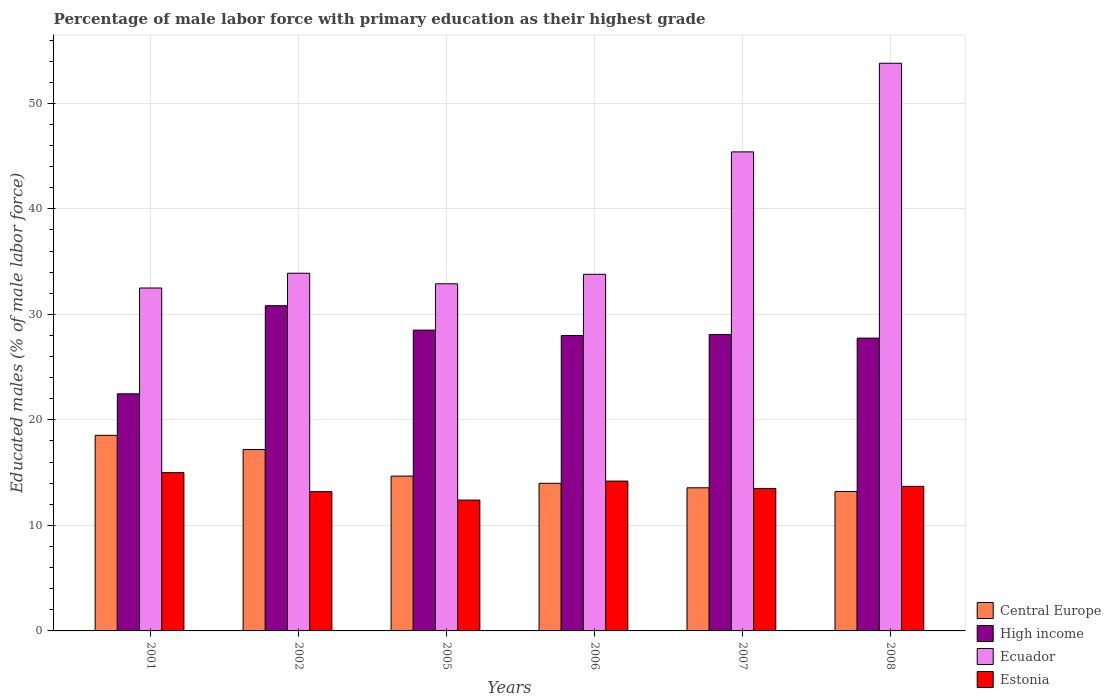Are the number of bars on each tick of the X-axis equal?
Ensure brevity in your answer.  Yes. How many bars are there on the 3rd tick from the right?
Ensure brevity in your answer.  4. In how many cases, is the number of bars for a given year not equal to the number of legend labels?
Provide a short and direct response. 0. What is the percentage of male labor force with primary education in High income in 2005?
Your answer should be compact. 28.51. Across all years, what is the maximum percentage of male labor force with primary education in Central Europe?
Ensure brevity in your answer.  18.54. Across all years, what is the minimum percentage of male labor force with primary education in Ecuador?
Offer a terse response. 32.5. In which year was the percentage of male labor force with primary education in Ecuador minimum?
Give a very brief answer. 2001. What is the total percentage of male labor force with primary education in High income in the graph?
Offer a terse response. 165.64. What is the difference between the percentage of male labor force with primary education in Central Europe in 2002 and that in 2006?
Ensure brevity in your answer.  3.2. What is the difference between the percentage of male labor force with primary education in Estonia in 2005 and the percentage of male labor force with primary education in Ecuador in 2006?
Ensure brevity in your answer.  -21.4. What is the average percentage of male labor force with primary education in Central Europe per year?
Offer a terse response. 15.2. In the year 2001, what is the difference between the percentage of male labor force with primary education in Central Europe and percentage of male labor force with primary education in High income?
Give a very brief answer. -3.93. In how many years, is the percentage of male labor force with primary education in Estonia greater than 22 %?
Ensure brevity in your answer.  0. What is the ratio of the percentage of male labor force with primary education in High income in 2001 to that in 2005?
Provide a short and direct response. 0.79. Is the percentage of male labor force with primary education in Estonia in 2001 less than that in 2005?
Your response must be concise. No. Is the difference between the percentage of male labor force with primary education in Central Europe in 2002 and 2005 greater than the difference between the percentage of male labor force with primary education in High income in 2002 and 2005?
Provide a short and direct response. Yes. What is the difference between the highest and the second highest percentage of male labor force with primary education in High income?
Your answer should be compact. 2.31. What is the difference between the highest and the lowest percentage of male labor force with primary education in High income?
Make the answer very short. 8.35. What does the 1st bar from the right in 2006 represents?
Provide a succinct answer. Estonia. How many bars are there?
Ensure brevity in your answer.  24. What is the difference between two consecutive major ticks on the Y-axis?
Offer a very short reply. 10. Does the graph contain any zero values?
Your response must be concise. No. Where does the legend appear in the graph?
Your response must be concise. Bottom right. How many legend labels are there?
Give a very brief answer. 4. How are the legend labels stacked?
Offer a very short reply. Vertical. What is the title of the graph?
Your answer should be very brief. Percentage of male labor force with primary education as their highest grade. What is the label or title of the X-axis?
Your answer should be compact. Years. What is the label or title of the Y-axis?
Keep it short and to the point. Educated males (% of male labor force). What is the Educated males (% of male labor force) in Central Europe in 2001?
Offer a terse response. 18.54. What is the Educated males (% of male labor force) of High income in 2001?
Keep it short and to the point. 22.47. What is the Educated males (% of male labor force) in Ecuador in 2001?
Provide a short and direct response. 32.5. What is the Educated males (% of male labor force) of Estonia in 2001?
Your response must be concise. 15. What is the Educated males (% of male labor force) of Central Europe in 2002?
Give a very brief answer. 17.19. What is the Educated males (% of male labor force) in High income in 2002?
Offer a very short reply. 30.82. What is the Educated males (% of male labor force) of Ecuador in 2002?
Make the answer very short. 33.9. What is the Educated males (% of male labor force) of Estonia in 2002?
Provide a short and direct response. 13.2. What is the Educated males (% of male labor force) in Central Europe in 2005?
Your response must be concise. 14.67. What is the Educated males (% of male labor force) in High income in 2005?
Your answer should be compact. 28.51. What is the Educated males (% of male labor force) of Ecuador in 2005?
Your answer should be very brief. 32.9. What is the Educated males (% of male labor force) in Estonia in 2005?
Offer a terse response. 12.4. What is the Educated males (% of male labor force) of Central Europe in 2006?
Your answer should be very brief. 13.99. What is the Educated males (% of male labor force) in High income in 2006?
Offer a terse response. 28. What is the Educated males (% of male labor force) in Ecuador in 2006?
Offer a very short reply. 33.8. What is the Educated males (% of male labor force) of Estonia in 2006?
Offer a terse response. 14.2. What is the Educated males (% of male labor force) of Central Europe in 2007?
Provide a short and direct response. 13.57. What is the Educated males (% of male labor force) of High income in 2007?
Offer a very short reply. 28.09. What is the Educated males (% of male labor force) of Ecuador in 2007?
Offer a very short reply. 45.4. What is the Educated males (% of male labor force) in Central Europe in 2008?
Keep it short and to the point. 13.22. What is the Educated males (% of male labor force) in High income in 2008?
Make the answer very short. 27.75. What is the Educated males (% of male labor force) in Ecuador in 2008?
Offer a very short reply. 53.8. What is the Educated males (% of male labor force) in Estonia in 2008?
Give a very brief answer. 13.7. Across all years, what is the maximum Educated males (% of male labor force) in Central Europe?
Give a very brief answer. 18.54. Across all years, what is the maximum Educated males (% of male labor force) in High income?
Provide a short and direct response. 30.82. Across all years, what is the maximum Educated males (% of male labor force) of Ecuador?
Offer a terse response. 53.8. Across all years, what is the maximum Educated males (% of male labor force) in Estonia?
Offer a terse response. 15. Across all years, what is the minimum Educated males (% of male labor force) of Central Europe?
Make the answer very short. 13.22. Across all years, what is the minimum Educated males (% of male labor force) of High income?
Your response must be concise. 22.47. Across all years, what is the minimum Educated males (% of male labor force) in Ecuador?
Provide a short and direct response. 32.5. Across all years, what is the minimum Educated males (% of male labor force) of Estonia?
Offer a terse response. 12.4. What is the total Educated males (% of male labor force) in Central Europe in the graph?
Offer a very short reply. 91.18. What is the total Educated males (% of male labor force) of High income in the graph?
Offer a very short reply. 165.64. What is the total Educated males (% of male labor force) in Ecuador in the graph?
Give a very brief answer. 232.3. What is the difference between the Educated males (% of male labor force) of Central Europe in 2001 and that in 2002?
Your response must be concise. 1.35. What is the difference between the Educated males (% of male labor force) of High income in 2001 and that in 2002?
Provide a short and direct response. -8.35. What is the difference between the Educated males (% of male labor force) in Estonia in 2001 and that in 2002?
Offer a very short reply. 1.8. What is the difference between the Educated males (% of male labor force) in Central Europe in 2001 and that in 2005?
Your response must be concise. 3.87. What is the difference between the Educated males (% of male labor force) of High income in 2001 and that in 2005?
Your response must be concise. -6.04. What is the difference between the Educated males (% of male labor force) in Ecuador in 2001 and that in 2005?
Your answer should be very brief. -0.4. What is the difference between the Educated males (% of male labor force) in Central Europe in 2001 and that in 2006?
Keep it short and to the point. 4.55. What is the difference between the Educated males (% of male labor force) in High income in 2001 and that in 2006?
Offer a terse response. -5.53. What is the difference between the Educated males (% of male labor force) in Ecuador in 2001 and that in 2006?
Give a very brief answer. -1.3. What is the difference between the Educated males (% of male labor force) of Central Europe in 2001 and that in 2007?
Ensure brevity in your answer.  4.97. What is the difference between the Educated males (% of male labor force) in High income in 2001 and that in 2007?
Offer a terse response. -5.62. What is the difference between the Educated males (% of male labor force) in Ecuador in 2001 and that in 2007?
Offer a very short reply. -12.9. What is the difference between the Educated males (% of male labor force) of Central Europe in 2001 and that in 2008?
Provide a short and direct response. 5.32. What is the difference between the Educated males (% of male labor force) in High income in 2001 and that in 2008?
Offer a terse response. -5.28. What is the difference between the Educated males (% of male labor force) in Ecuador in 2001 and that in 2008?
Offer a very short reply. -21.3. What is the difference between the Educated males (% of male labor force) of Central Europe in 2002 and that in 2005?
Your answer should be compact. 2.52. What is the difference between the Educated males (% of male labor force) of High income in 2002 and that in 2005?
Your answer should be compact. 2.31. What is the difference between the Educated males (% of male labor force) in Estonia in 2002 and that in 2005?
Offer a very short reply. 0.8. What is the difference between the Educated males (% of male labor force) of Central Europe in 2002 and that in 2006?
Ensure brevity in your answer.  3.2. What is the difference between the Educated males (% of male labor force) in High income in 2002 and that in 2006?
Offer a terse response. 2.82. What is the difference between the Educated males (% of male labor force) in Central Europe in 2002 and that in 2007?
Make the answer very short. 3.62. What is the difference between the Educated males (% of male labor force) in High income in 2002 and that in 2007?
Give a very brief answer. 2.73. What is the difference between the Educated males (% of male labor force) of Ecuador in 2002 and that in 2007?
Provide a succinct answer. -11.5. What is the difference between the Educated males (% of male labor force) in Central Europe in 2002 and that in 2008?
Your answer should be compact. 3.97. What is the difference between the Educated males (% of male labor force) in High income in 2002 and that in 2008?
Your answer should be compact. 3.07. What is the difference between the Educated males (% of male labor force) of Ecuador in 2002 and that in 2008?
Ensure brevity in your answer.  -19.9. What is the difference between the Educated males (% of male labor force) in Central Europe in 2005 and that in 2006?
Your answer should be compact. 0.68. What is the difference between the Educated males (% of male labor force) of High income in 2005 and that in 2006?
Provide a short and direct response. 0.51. What is the difference between the Educated males (% of male labor force) in Ecuador in 2005 and that in 2006?
Offer a terse response. -0.9. What is the difference between the Educated males (% of male labor force) in Estonia in 2005 and that in 2006?
Offer a very short reply. -1.8. What is the difference between the Educated males (% of male labor force) in Central Europe in 2005 and that in 2007?
Provide a short and direct response. 1.11. What is the difference between the Educated males (% of male labor force) in High income in 2005 and that in 2007?
Give a very brief answer. 0.42. What is the difference between the Educated males (% of male labor force) in Ecuador in 2005 and that in 2007?
Provide a succinct answer. -12.5. What is the difference between the Educated males (% of male labor force) in Estonia in 2005 and that in 2007?
Provide a short and direct response. -1.1. What is the difference between the Educated males (% of male labor force) in Central Europe in 2005 and that in 2008?
Your response must be concise. 1.46. What is the difference between the Educated males (% of male labor force) in High income in 2005 and that in 2008?
Provide a succinct answer. 0.76. What is the difference between the Educated males (% of male labor force) of Ecuador in 2005 and that in 2008?
Your response must be concise. -20.9. What is the difference between the Educated males (% of male labor force) of Estonia in 2005 and that in 2008?
Give a very brief answer. -1.3. What is the difference between the Educated males (% of male labor force) in Central Europe in 2006 and that in 2007?
Offer a terse response. 0.43. What is the difference between the Educated males (% of male labor force) in High income in 2006 and that in 2007?
Offer a very short reply. -0.09. What is the difference between the Educated males (% of male labor force) of Estonia in 2006 and that in 2007?
Your answer should be compact. 0.7. What is the difference between the Educated males (% of male labor force) in Central Europe in 2006 and that in 2008?
Keep it short and to the point. 0.78. What is the difference between the Educated males (% of male labor force) of High income in 2006 and that in 2008?
Ensure brevity in your answer.  0.25. What is the difference between the Educated males (% of male labor force) in Estonia in 2006 and that in 2008?
Provide a short and direct response. 0.5. What is the difference between the Educated males (% of male labor force) of Central Europe in 2007 and that in 2008?
Ensure brevity in your answer.  0.35. What is the difference between the Educated males (% of male labor force) in High income in 2007 and that in 2008?
Give a very brief answer. 0.34. What is the difference between the Educated males (% of male labor force) of Estonia in 2007 and that in 2008?
Keep it short and to the point. -0.2. What is the difference between the Educated males (% of male labor force) of Central Europe in 2001 and the Educated males (% of male labor force) of High income in 2002?
Your answer should be compact. -12.28. What is the difference between the Educated males (% of male labor force) of Central Europe in 2001 and the Educated males (% of male labor force) of Ecuador in 2002?
Provide a short and direct response. -15.36. What is the difference between the Educated males (% of male labor force) in Central Europe in 2001 and the Educated males (% of male labor force) in Estonia in 2002?
Provide a short and direct response. 5.34. What is the difference between the Educated males (% of male labor force) in High income in 2001 and the Educated males (% of male labor force) in Ecuador in 2002?
Give a very brief answer. -11.43. What is the difference between the Educated males (% of male labor force) of High income in 2001 and the Educated males (% of male labor force) of Estonia in 2002?
Make the answer very short. 9.27. What is the difference between the Educated males (% of male labor force) of Ecuador in 2001 and the Educated males (% of male labor force) of Estonia in 2002?
Provide a succinct answer. 19.3. What is the difference between the Educated males (% of male labor force) in Central Europe in 2001 and the Educated males (% of male labor force) in High income in 2005?
Keep it short and to the point. -9.97. What is the difference between the Educated males (% of male labor force) in Central Europe in 2001 and the Educated males (% of male labor force) in Ecuador in 2005?
Provide a short and direct response. -14.36. What is the difference between the Educated males (% of male labor force) of Central Europe in 2001 and the Educated males (% of male labor force) of Estonia in 2005?
Keep it short and to the point. 6.14. What is the difference between the Educated males (% of male labor force) of High income in 2001 and the Educated males (% of male labor force) of Ecuador in 2005?
Offer a terse response. -10.43. What is the difference between the Educated males (% of male labor force) of High income in 2001 and the Educated males (% of male labor force) of Estonia in 2005?
Make the answer very short. 10.07. What is the difference between the Educated males (% of male labor force) of Ecuador in 2001 and the Educated males (% of male labor force) of Estonia in 2005?
Make the answer very short. 20.1. What is the difference between the Educated males (% of male labor force) in Central Europe in 2001 and the Educated males (% of male labor force) in High income in 2006?
Your response must be concise. -9.46. What is the difference between the Educated males (% of male labor force) in Central Europe in 2001 and the Educated males (% of male labor force) in Ecuador in 2006?
Your answer should be compact. -15.26. What is the difference between the Educated males (% of male labor force) of Central Europe in 2001 and the Educated males (% of male labor force) of Estonia in 2006?
Keep it short and to the point. 4.34. What is the difference between the Educated males (% of male labor force) in High income in 2001 and the Educated males (% of male labor force) in Ecuador in 2006?
Your response must be concise. -11.33. What is the difference between the Educated males (% of male labor force) in High income in 2001 and the Educated males (% of male labor force) in Estonia in 2006?
Make the answer very short. 8.27. What is the difference between the Educated males (% of male labor force) of Central Europe in 2001 and the Educated males (% of male labor force) of High income in 2007?
Make the answer very short. -9.55. What is the difference between the Educated males (% of male labor force) of Central Europe in 2001 and the Educated males (% of male labor force) of Ecuador in 2007?
Provide a succinct answer. -26.86. What is the difference between the Educated males (% of male labor force) in Central Europe in 2001 and the Educated males (% of male labor force) in Estonia in 2007?
Provide a succinct answer. 5.04. What is the difference between the Educated males (% of male labor force) of High income in 2001 and the Educated males (% of male labor force) of Ecuador in 2007?
Your answer should be very brief. -22.93. What is the difference between the Educated males (% of male labor force) in High income in 2001 and the Educated males (% of male labor force) in Estonia in 2007?
Offer a terse response. 8.97. What is the difference between the Educated males (% of male labor force) of Central Europe in 2001 and the Educated males (% of male labor force) of High income in 2008?
Make the answer very short. -9.21. What is the difference between the Educated males (% of male labor force) in Central Europe in 2001 and the Educated males (% of male labor force) in Ecuador in 2008?
Offer a very short reply. -35.26. What is the difference between the Educated males (% of male labor force) in Central Europe in 2001 and the Educated males (% of male labor force) in Estonia in 2008?
Offer a very short reply. 4.84. What is the difference between the Educated males (% of male labor force) in High income in 2001 and the Educated males (% of male labor force) in Ecuador in 2008?
Give a very brief answer. -31.33. What is the difference between the Educated males (% of male labor force) of High income in 2001 and the Educated males (% of male labor force) of Estonia in 2008?
Make the answer very short. 8.77. What is the difference between the Educated males (% of male labor force) in Central Europe in 2002 and the Educated males (% of male labor force) in High income in 2005?
Give a very brief answer. -11.32. What is the difference between the Educated males (% of male labor force) in Central Europe in 2002 and the Educated males (% of male labor force) in Ecuador in 2005?
Give a very brief answer. -15.71. What is the difference between the Educated males (% of male labor force) in Central Europe in 2002 and the Educated males (% of male labor force) in Estonia in 2005?
Your response must be concise. 4.79. What is the difference between the Educated males (% of male labor force) of High income in 2002 and the Educated males (% of male labor force) of Ecuador in 2005?
Your answer should be compact. -2.08. What is the difference between the Educated males (% of male labor force) of High income in 2002 and the Educated males (% of male labor force) of Estonia in 2005?
Ensure brevity in your answer.  18.42. What is the difference between the Educated males (% of male labor force) in Central Europe in 2002 and the Educated males (% of male labor force) in High income in 2006?
Provide a short and direct response. -10.81. What is the difference between the Educated males (% of male labor force) in Central Europe in 2002 and the Educated males (% of male labor force) in Ecuador in 2006?
Ensure brevity in your answer.  -16.61. What is the difference between the Educated males (% of male labor force) of Central Europe in 2002 and the Educated males (% of male labor force) of Estonia in 2006?
Your response must be concise. 2.99. What is the difference between the Educated males (% of male labor force) of High income in 2002 and the Educated males (% of male labor force) of Ecuador in 2006?
Keep it short and to the point. -2.98. What is the difference between the Educated males (% of male labor force) in High income in 2002 and the Educated males (% of male labor force) in Estonia in 2006?
Give a very brief answer. 16.62. What is the difference between the Educated males (% of male labor force) in Ecuador in 2002 and the Educated males (% of male labor force) in Estonia in 2006?
Provide a short and direct response. 19.7. What is the difference between the Educated males (% of male labor force) in Central Europe in 2002 and the Educated males (% of male labor force) in High income in 2007?
Your answer should be compact. -10.9. What is the difference between the Educated males (% of male labor force) in Central Europe in 2002 and the Educated males (% of male labor force) in Ecuador in 2007?
Offer a terse response. -28.21. What is the difference between the Educated males (% of male labor force) in Central Europe in 2002 and the Educated males (% of male labor force) in Estonia in 2007?
Ensure brevity in your answer.  3.69. What is the difference between the Educated males (% of male labor force) in High income in 2002 and the Educated males (% of male labor force) in Ecuador in 2007?
Provide a short and direct response. -14.58. What is the difference between the Educated males (% of male labor force) in High income in 2002 and the Educated males (% of male labor force) in Estonia in 2007?
Offer a very short reply. 17.32. What is the difference between the Educated males (% of male labor force) in Ecuador in 2002 and the Educated males (% of male labor force) in Estonia in 2007?
Your answer should be compact. 20.4. What is the difference between the Educated males (% of male labor force) in Central Europe in 2002 and the Educated males (% of male labor force) in High income in 2008?
Offer a very short reply. -10.56. What is the difference between the Educated males (% of male labor force) in Central Europe in 2002 and the Educated males (% of male labor force) in Ecuador in 2008?
Ensure brevity in your answer.  -36.61. What is the difference between the Educated males (% of male labor force) in Central Europe in 2002 and the Educated males (% of male labor force) in Estonia in 2008?
Your answer should be compact. 3.49. What is the difference between the Educated males (% of male labor force) of High income in 2002 and the Educated males (% of male labor force) of Ecuador in 2008?
Give a very brief answer. -22.98. What is the difference between the Educated males (% of male labor force) of High income in 2002 and the Educated males (% of male labor force) of Estonia in 2008?
Offer a terse response. 17.12. What is the difference between the Educated males (% of male labor force) in Ecuador in 2002 and the Educated males (% of male labor force) in Estonia in 2008?
Ensure brevity in your answer.  20.2. What is the difference between the Educated males (% of male labor force) of Central Europe in 2005 and the Educated males (% of male labor force) of High income in 2006?
Make the answer very short. -13.32. What is the difference between the Educated males (% of male labor force) in Central Europe in 2005 and the Educated males (% of male labor force) in Ecuador in 2006?
Give a very brief answer. -19.13. What is the difference between the Educated males (% of male labor force) of Central Europe in 2005 and the Educated males (% of male labor force) of Estonia in 2006?
Give a very brief answer. 0.47. What is the difference between the Educated males (% of male labor force) in High income in 2005 and the Educated males (% of male labor force) in Ecuador in 2006?
Keep it short and to the point. -5.29. What is the difference between the Educated males (% of male labor force) of High income in 2005 and the Educated males (% of male labor force) of Estonia in 2006?
Offer a very short reply. 14.31. What is the difference between the Educated males (% of male labor force) of Ecuador in 2005 and the Educated males (% of male labor force) of Estonia in 2006?
Your answer should be compact. 18.7. What is the difference between the Educated males (% of male labor force) in Central Europe in 2005 and the Educated males (% of male labor force) in High income in 2007?
Offer a very short reply. -13.42. What is the difference between the Educated males (% of male labor force) of Central Europe in 2005 and the Educated males (% of male labor force) of Ecuador in 2007?
Keep it short and to the point. -30.73. What is the difference between the Educated males (% of male labor force) of Central Europe in 2005 and the Educated males (% of male labor force) of Estonia in 2007?
Provide a short and direct response. 1.17. What is the difference between the Educated males (% of male labor force) of High income in 2005 and the Educated males (% of male labor force) of Ecuador in 2007?
Make the answer very short. -16.89. What is the difference between the Educated males (% of male labor force) in High income in 2005 and the Educated males (% of male labor force) in Estonia in 2007?
Provide a short and direct response. 15.01. What is the difference between the Educated males (% of male labor force) in Ecuador in 2005 and the Educated males (% of male labor force) in Estonia in 2007?
Provide a short and direct response. 19.4. What is the difference between the Educated males (% of male labor force) of Central Europe in 2005 and the Educated males (% of male labor force) of High income in 2008?
Keep it short and to the point. -13.08. What is the difference between the Educated males (% of male labor force) of Central Europe in 2005 and the Educated males (% of male labor force) of Ecuador in 2008?
Your response must be concise. -39.13. What is the difference between the Educated males (% of male labor force) of Central Europe in 2005 and the Educated males (% of male labor force) of Estonia in 2008?
Offer a very short reply. 0.97. What is the difference between the Educated males (% of male labor force) in High income in 2005 and the Educated males (% of male labor force) in Ecuador in 2008?
Give a very brief answer. -25.29. What is the difference between the Educated males (% of male labor force) in High income in 2005 and the Educated males (% of male labor force) in Estonia in 2008?
Provide a short and direct response. 14.81. What is the difference between the Educated males (% of male labor force) in Ecuador in 2005 and the Educated males (% of male labor force) in Estonia in 2008?
Keep it short and to the point. 19.2. What is the difference between the Educated males (% of male labor force) of Central Europe in 2006 and the Educated males (% of male labor force) of High income in 2007?
Your answer should be very brief. -14.1. What is the difference between the Educated males (% of male labor force) in Central Europe in 2006 and the Educated males (% of male labor force) in Ecuador in 2007?
Ensure brevity in your answer.  -31.41. What is the difference between the Educated males (% of male labor force) in Central Europe in 2006 and the Educated males (% of male labor force) in Estonia in 2007?
Your answer should be compact. 0.49. What is the difference between the Educated males (% of male labor force) in High income in 2006 and the Educated males (% of male labor force) in Ecuador in 2007?
Offer a very short reply. -17.4. What is the difference between the Educated males (% of male labor force) of High income in 2006 and the Educated males (% of male labor force) of Estonia in 2007?
Make the answer very short. 14.5. What is the difference between the Educated males (% of male labor force) in Ecuador in 2006 and the Educated males (% of male labor force) in Estonia in 2007?
Offer a terse response. 20.3. What is the difference between the Educated males (% of male labor force) of Central Europe in 2006 and the Educated males (% of male labor force) of High income in 2008?
Keep it short and to the point. -13.76. What is the difference between the Educated males (% of male labor force) in Central Europe in 2006 and the Educated males (% of male labor force) in Ecuador in 2008?
Provide a succinct answer. -39.81. What is the difference between the Educated males (% of male labor force) of Central Europe in 2006 and the Educated males (% of male labor force) of Estonia in 2008?
Ensure brevity in your answer.  0.29. What is the difference between the Educated males (% of male labor force) in High income in 2006 and the Educated males (% of male labor force) in Ecuador in 2008?
Your answer should be compact. -25.8. What is the difference between the Educated males (% of male labor force) in High income in 2006 and the Educated males (% of male labor force) in Estonia in 2008?
Your response must be concise. 14.3. What is the difference between the Educated males (% of male labor force) of Ecuador in 2006 and the Educated males (% of male labor force) of Estonia in 2008?
Your response must be concise. 20.1. What is the difference between the Educated males (% of male labor force) in Central Europe in 2007 and the Educated males (% of male labor force) in High income in 2008?
Keep it short and to the point. -14.19. What is the difference between the Educated males (% of male labor force) of Central Europe in 2007 and the Educated males (% of male labor force) of Ecuador in 2008?
Ensure brevity in your answer.  -40.23. What is the difference between the Educated males (% of male labor force) of Central Europe in 2007 and the Educated males (% of male labor force) of Estonia in 2008?
Your answer should be compact. -0.13. What is the difference between the Educated males (% of male labor force) in High income in 2007 and the Educated males (% of male labor force) in Ecuador in 2008?
Provide a succinct answer. -25.71. What is the difference between the Educated males (% of male labor force) in High income in 2007 and the Educated males (% of male labor force) in Estonia in 2008?
Give a very brief answer. 14.39. What is the difference between the Educated males (% of male labor force) in Ecuador in 2007 and the Educated males (% of male labor force) in Estonia in 2008?
Your response must be concise. 31.7. What is the average Educated males (% of male labor force) of Central Europe per year?
Make the answer very short. 15.2. What is the average Educated males (% of male labor force) of High income per year?
Your answer should be very brief. 27.61. What is the average Educated males (% of male labor force) in Ecuador per year?
Your response must be concise. 38.72. What is the average Educated males (% of male labor force) in Estonia per year?
Your response must be concise. 13.67. In the year 2001, what is the difference between the Educated males (% of male labor force) in Central Europe and Educated males (% of male labor force) in High income?
Provide a short and direct response. -3.93. In the year 2001, what is the difference between the Educated males (% of male labor force) of Central Europe and Educated males (% of male labor force) of Ecuador?
Offer a very short reply. -13.96. In the year 2001, what is the difference between the Educated males (% of male labor force) of Central Europe and Educated males (% of male labor force) of Estonia?
Provide a succinct answer. 3.54. In the year 2001, what is the difference between the Educated males (% of male labor force) in High income and Educated males (% of male labor force) in Ecuador?
Provide a succinct answer. -10.03. In the year 2001, what is the difference between the Educated males (% of male labor force) in High income and Educated males (% of male labor force) in Estonia?
Provide a short and direct response. 7.47. In the year 2002, what is the difference between the Educated males (% of male labor force) of Central Europe and Educated males (% of male labor force) of High income?
Your response must be concise. -13.63. In the year 2002, what is the difference between the Educated males (% of male labor force) of Central Europe and Educated males (% of male labor force) of Ecuador?
Your answer should be compact. -16.71. In the year 2002, what is the difference between the Educated males (% of male labor force) in Central Europe and Educated males (% of male labor force) in Estonia?
Ensure brevity in your answer.  3.99. In the year 2002, what is the difference between the Educated males (% of male labor force) of High income and Educated males (% of male labor force) of Ecuador?
Your answer should be compact. -3.08. In the year 2002, what is the difference between the Educated males (% of male labor force) in High income and Educated males (% of male labor force) in Estonia?
Make the answer very short. 17.62. In the year 2002, what is the difference between the Educated males (% of male labor force) in Ecuador and Educated males (% of male labor force) in Estonia?
Provide a succinct answer. 20.7. In the year 2005, what is the difference between the Educated males (% of male labor force) of Central Europe and Educated males (% of male labor force) of High income?
Offer a terse response. -13.84. In the year 2005, what is the difference between the Educated males (% of male labor force) of Central Europe and Educated males (% of male labor force) of Ecuador?
Offer a very short reply. -18.23. In the year 2005, what is the difference between the Educated males (% of male labor force) of Central Europe and Educated males (% of male labor force) of Estonia?
Provide a short and direct response. 2.27. In the year 2005, what is the difference between the Educated males (% of male labor force) in High income and Educated males (% of male labor force) in Ecuador?
Your answer should be very brief. -4.39. In the year 2005, what is the difference between the Educated males (% of male labor force) of High income and Educated males (% of male labor force) of Estonia?
Ensure brevity in your answer.  16.11. In the year 2006, what is the difference between the Educated males (% of male labor force) of Central Europe and Educated males (% of male labor force) of High income?
Your answer should be compact. -14. In the year 2006, what is the difference between the Educated males (% of male labor force) in Central Europe and Educated males (% of male labor force) in Ecuador?
Give a very brief answer. -19.81. In the year 2006, what is the difference between the Educated males (% of male labor force) of Central Europe and Educated males (% of male labor force) of Estonia?
Provide a short and direct response. -0.21. In the year 2006, what is the difference between the Educated males (% of male labor force) of High income and Educated males (% of male labor force) of Ecuador?
Provide a short and direct response. -5.8. In the year 2006, what is the difference between the Educated males (% of male labor force) in High income and Educated males (% of male labor force) in Estonia?
Your answer should be very brief. 13.8. In the year 2006, what is the difference between the Educated males (% of male labor force) in Ecuador and Educated males (% of male labor force) in Estonia?
Keep it short and to the point. 19.6. In the year 2007, what is the difference between the Educated males (% of male labor force) of Central Europe and Educated males (% of male labor force) of High income?
Provide a succinct answer. -14.52. In the year 2007, what is the difference between the Educated males (% of male labor force) in Central Europe and Educated males (% of male labor force) in Ecuador?
Offer a very short reply. -31.83. In the year 2007, what is the difference between the Educated males (% of male labor force) in Central Europe and Educated males (% of male labor force) in Estonia?
Provide a short and direct response. 0.07. In the year 2007, what is the difference between the Educated males (% of male labor force) in High income and Educated males (% of male labor force) in Ecuador?
Offer a very short reply. -17.31. In the year 2007, what is the difference between the Educated males (% of male labor force) of High income and Educated males (% of male labor force) of Estonia?
Make the answer very short. 14.59. In the year 2007, what is the difference between the Educated males (% of male labor force) of Ecuador and Educated males (% of male labor force) of Estonia?
Keep it short and to the point. 31.9. In the year 2008, what is the difference between the Educated males (% of male labor force) of Central Europe and Educated males (% of male labor force) of High income?
Your answer should be very brief. -14.53. In the year 2008, what is the difference between the Educated males (% of male labor force) of Central Europe and Educated males (% of male labor force) of Ecuador?
Make the answer very short. -40.58. In the year 2008, what is the difference between the Educated males (% of male labor force) of Central Europe and Educated males (% of male labor force) of Estonia?
Your answer should be compact. -0.48. In the year 2008, what is the difference between the Educated males (% of male labor force) of High income and Educated males (% of male labor force) of Ecuador?
Keep it short and to the point. -26.05. In the year 2008, what is the difference between the Educated males (% of male labor force) of High income and Educated males (% of male labor force) of Estonia?
Your answer should be very brief. 14.05. In the year 2008, what is the difference between the Educated males (% of male labor force) in Ecuador and Educated males (% of male labor force) in Estonia?
Keep it short and to the point. 40.1. What is the ratio of the Educated males (% of male labor force) of Central Europe in 2001 to that in 2002?
Your answer should be very brief. 1.08. What is the ratio of the Educated males (% of male labor force) of High income in 2001 to that in 2002?
Provide a short and direct response. 0.73. What is the ratio of the Educated males (% of male labor force) in Ecuador in 2001 to that in 2002?
Ensure brevity in your answer.  0.96. What is the ratio of the Educated males (% of male labor force) in Estonia in 2001 to that in 2002?
Provide a succinct answer. 1.14. What is the ratio of the Educated males (% of male labor force) in Central Europe in 2001 to that in 2005?
Keep it short and to the point. 1.26. What is the ratio of the Educated males (% of male labor force) of High income in 2001 to that in 2005?
Provide a succinct answer. 0.79. What is the ratio of the Educated males (% of male labor force) in Ecuador in 2001 to that in 2005?
Give a very brief answer. 0.99. What is the ratio of the Educated males (% of male labor force) of Estonia in 2001 to that in 2005?
Give a very brief answer. 1.21. What is the ratio of the Educated males (% of male labor force) of Central Europe in 2001 to that in 2006?
Your response must be concise. 1.32. What is the ratio of the Educated males (% of male labor force) of High income in 2001 to that in 2006?
Offer a terse response. 0.8. What is the ratio of the Educated males (% of male labor force) in Ecuador in 2001 to that in 2006?
Your answer should be very brief. 0.96. What is the ratio of the Educated males (% of male labor force) of Estonia in 2001 to that in 2006?
Provide a succinct answer. 1.06. What is the ratio of the Educated males (% of male labor force) in Central Europe in 2001 to that in 2007?
Offer a terse response. 1.37. What is the ratio of the Educated males (% of male labor force) of Ecuador in 2001 to that in 2007?
Offer a terse response. 0.72. What is the ratio of the Educated males (% of male labor force) of Central Europe in 2001 to that in 2008?
Keep it short and to the point. 1.4. What is the ratio of the Educated males (% of male labor force) in High income in 2001 to that in 2008?
Make the answer very short. 0.81. What is the ratio of the Educated males (% of male labor force) in Ecuador in 2001 to that in 2008?
Your answer should be very brief. 0.6. What is the ratio of the Educated males (% of male labor force) of Estonia in 2001 to that in 2008?
Keep it short and to the point. 1.09. What is the ratio of the Educated males (% of male labor force) of Central Europe in 2002 to that in 2005?
Ensure brevity in your answer.  1.17. What is the ratio of the Educated males (% of male labor force) in High income in 2002 to that in 2005?
Give a very brief answer. 1.08. What is the ratio of the Educated males (% of male labor force) in Ecuador in 2002 to that in 2005?
Ensure brevity in your answer.  1.03. What is the ratio of the Educated males (% of male labor force) in Estonia in 2002 to that in 2005?
Give a very brief answer. 1.06. What is the ratio of the Educated males (% of male labor force) in Central Europe in 2002 to that in 2006?
Provide a short and direct response. 1.23. What is the ratio of the Educated males (% of male labor force) in High income in 2002 to that in 2006?
Provide a succinct answer. 1.1. What is the ratio of the Educated males (% of male labor force) in Ecuador in 2002 to that in 2006?
Provide a short and direct response. 1. What is the ratio of the Educated males (% of male labor force) in Estonia in 2002 to that in 2006?
Offer a very short reply. 0.93. What is the ratio of the Educated males (% of male labor force) of Central Europe in 2002 to that in 2007?
Provide a succinct answer. 1.27. What is the ratio of the Educated males (% of male labor force) in High income in 2002 to that in 2007?
Provide a succinct answer. 1.1. What is the ratio of the Educated males (% of male labor force) in Ecuador in 2002 to that in 2007?
Provide a succinct answer. 0.75. What is the ratio of the Educated males (% of male labor force) of Estonia in 2002 to that in 2007?
Provide a succinct answer. 0.98. What is the ratio of the Educated males (% of male labor force) of Central Europe in 2002 to that in 2008?
Keep it short and to the point. 1.3. What is the ratio of the Educated males (% of male labor force) of High income in 2002 to that in 2008?
Offer a terse response. 1.11. What is the ratio of the Educated males (% of male labor force) in Ecuador in 2002 to that in 2008?
Keep it short and to the point. 0.63. What is the ratio of the Educated males (% of male labor force) of Estonia in 2002 to that in 2008?
Give a very brief answer. 0.96. What is the ratio of the Educated males (% of male labor force) of Central Europe in 2005 to that in 2006?
Offer a terse response. 1.05. What is the ratio of the Educated males (% of male labor force) in High income in 2005 to that in 2006?
Make the answer very short. 1.02. What is the ratio of the Educated males (% of male labor force) in Ecuador in 2005 to that in 2006?
Your answer should be compact. 0.97. What is the ratio of the Educated males (% of male labor force) in Estonia in 2005 to that in 2006?
Make the answer very short. 0.87. What is the ratio of the Educated males (% of male labor force) in Central Europe in 2005 to that in 2007?
Your answer should be compact. 1.08. What is the ratio of the Educated males (% of male labor force) of High income in 2005 to that in 2007?
Your answer should be very brief. 1.01. What is the ratio of the Educated males (% of male labor force) of Ecuador in 2005 to that in 2007?
Provide a succinct answer. 0.72. What is the ratio of the Educated males (% of male labor force) of Estonia in 2005 to that in 2007?
Offer a very short reply. 0.92. What is the ratio of the Educated males (% of male labor force) of Central Europe in 2005 to that in 2008?
Ensure brevity in your answer.  1.11. What is the ratio of the Educated males (% of male labor force) in High income in 2005 to that in 2008?
Offer a very short reply. 1.03. What is the ratio of the Educated males (% of male labor force) in Ecuador in 2005 to that in 2008?
Offer a very short reply. 0.61. What is the ratio of the Educated males (% of male labor force) in Estonia in 2005 to that in 2008?
Make the answer very short. 0.91. What is the ratio of the Educated males (% of male labor force) in Central Europe in 2006 to that in 2007?
Your answer should be very brief. 1.03. What is the ratio of the Educated males (% of male labor force) of Ecuador in 2006 to that in 2007?
Provide a succinct answer. 0.74. What is the ratio of the Educated males (% of male labor force) in Estonia in 2006 to that in 2007?
Offer a terse response. 1.05. What is the ratio of the Educated males (% of male labor force) of Central Europe in 2006 to that in 2008?
Offer a terse response. 1.06. What is the ratio of the Educated males (% of male labor force) of High income in 2006 to that in 2008?
Ensure brevity in your answer.  1.01. What is the ratio of the Educated males (% of male labor force) of Ecuador in 2006 to that in 2008?
Provide a short and direct response. 0.63. What is the ratio of the Educated males (% of male labor force) in Estonia in 2006 to that in 2008?
Keep it short and to the point. 1.04. What is the ratio of the Educated males (% of male labor force) of Central Europe in 2007 to that in 2008?
Your answer should be compact. 1.03. What is the ratio of the Educated males (% of male labor force) of High income in 2007 to that in 2008?
Your answer should be very brief. 1.01. What is the ratio of the Educated males (% of male labor force) in Ecuador in 2007 to that in 2008?
Make the answer very short. 0.84. What is the ratio of the Educated males (% of male labor force) in Estonia in 2007 to that in 2008?
Ensure brevity in your answer.  0.99. What is the difference between the highest and the second highest Educated males (% of male labor force) of Central Europe?
Offer a very short reply. 1.35. What is the difference between the highest and the second highest Educated males (% of male labor force) of High income?
Your answer should be very brief. 2.31. What is the difference between the highest and the second highest Educated males (% of male labor force) of Ecuador?
Keep it short and to the point. 8.4. What is the difference between the highest and the lowest Educated males (% of male labor force) of Central Europe?
Make the answer very short. 5.32. What is the difference between the highest and the lowest Educated males (% of male labor force) in High income?
Your answer should be compact. 8.35. What is the difference between the highest and the lowest Educated males (% of male labor force) in Ecuador?
Keep it short and to the point. 21.3. What is the difference between the highest and the lowest Educated males (% of male labor force) of Estonia?
Provide a short and direct response. 2.6. 